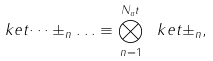Convert formula to latex. <formula><loc_0><loc_0><loc_500><loc_500>\ k e t { \dots \pm _ { n } \dots } \equiv \bigotimes _ { n = 1 } ^ { N _ { a } t } \ k e t { \pm _ { n } } ,</formula> 